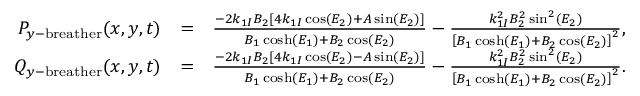<formula> <loc_0><loc_0><loc_500><loc_500>\begin{array} { r l r } { P _ { y - b r e a t h e r } ( x , y , t ) } & { = } & { \frac { - 2 k _ { 1 I } B _ { 2 } \left [ 4 k _ { 1 I } \cos ( E _ { 2 } ) + A \sin ( E _ { 2 } ) \right ] } { B _ { 1 } \cosh ( E _ { 1 } ) + B _ { 2 } \cos ( E _ { 2 } ) } - \frac { k _ { 1 I } ^ { 2 } B _ { 2 } ^ { 2 } \sin ^ { 2 } ( E _ { 2 } ) } { \left [ B _ { 1 } \cosh ( E _ { 1 } ) + B _ { 2 } \cos ( E _ { 2 } ) \right ] ^ { 2 } } , \quad } \\ { Q _ { y - b r e a t h e r } ( x , y , t ) } & { = } & { \frac { - 2 k _ { 1 I } B _ { 2 } \left [ 4 k _ { 1 I } \cos ( E _ { 2 } ) - A \sin ( E _ { 2 } ) \right ] } { B _ { 1 } \cosh ( E _ { 1 } ) + B _ { 2 } \cos ( E _ { 2 } ) } - \frac { k _ { 1 I } ^ { 2 } B _ { 2 } ^ { 2 } \sin ^ { 2 } ( E _ { 2 } ) } { \left [ B _ { 1 } \cosh ( E _ { 1 } ) + B _ { 2 } \cos ( E _ { 2 } ) \right ] ^ { 2 } } . \quad } \end{array}</formula> 